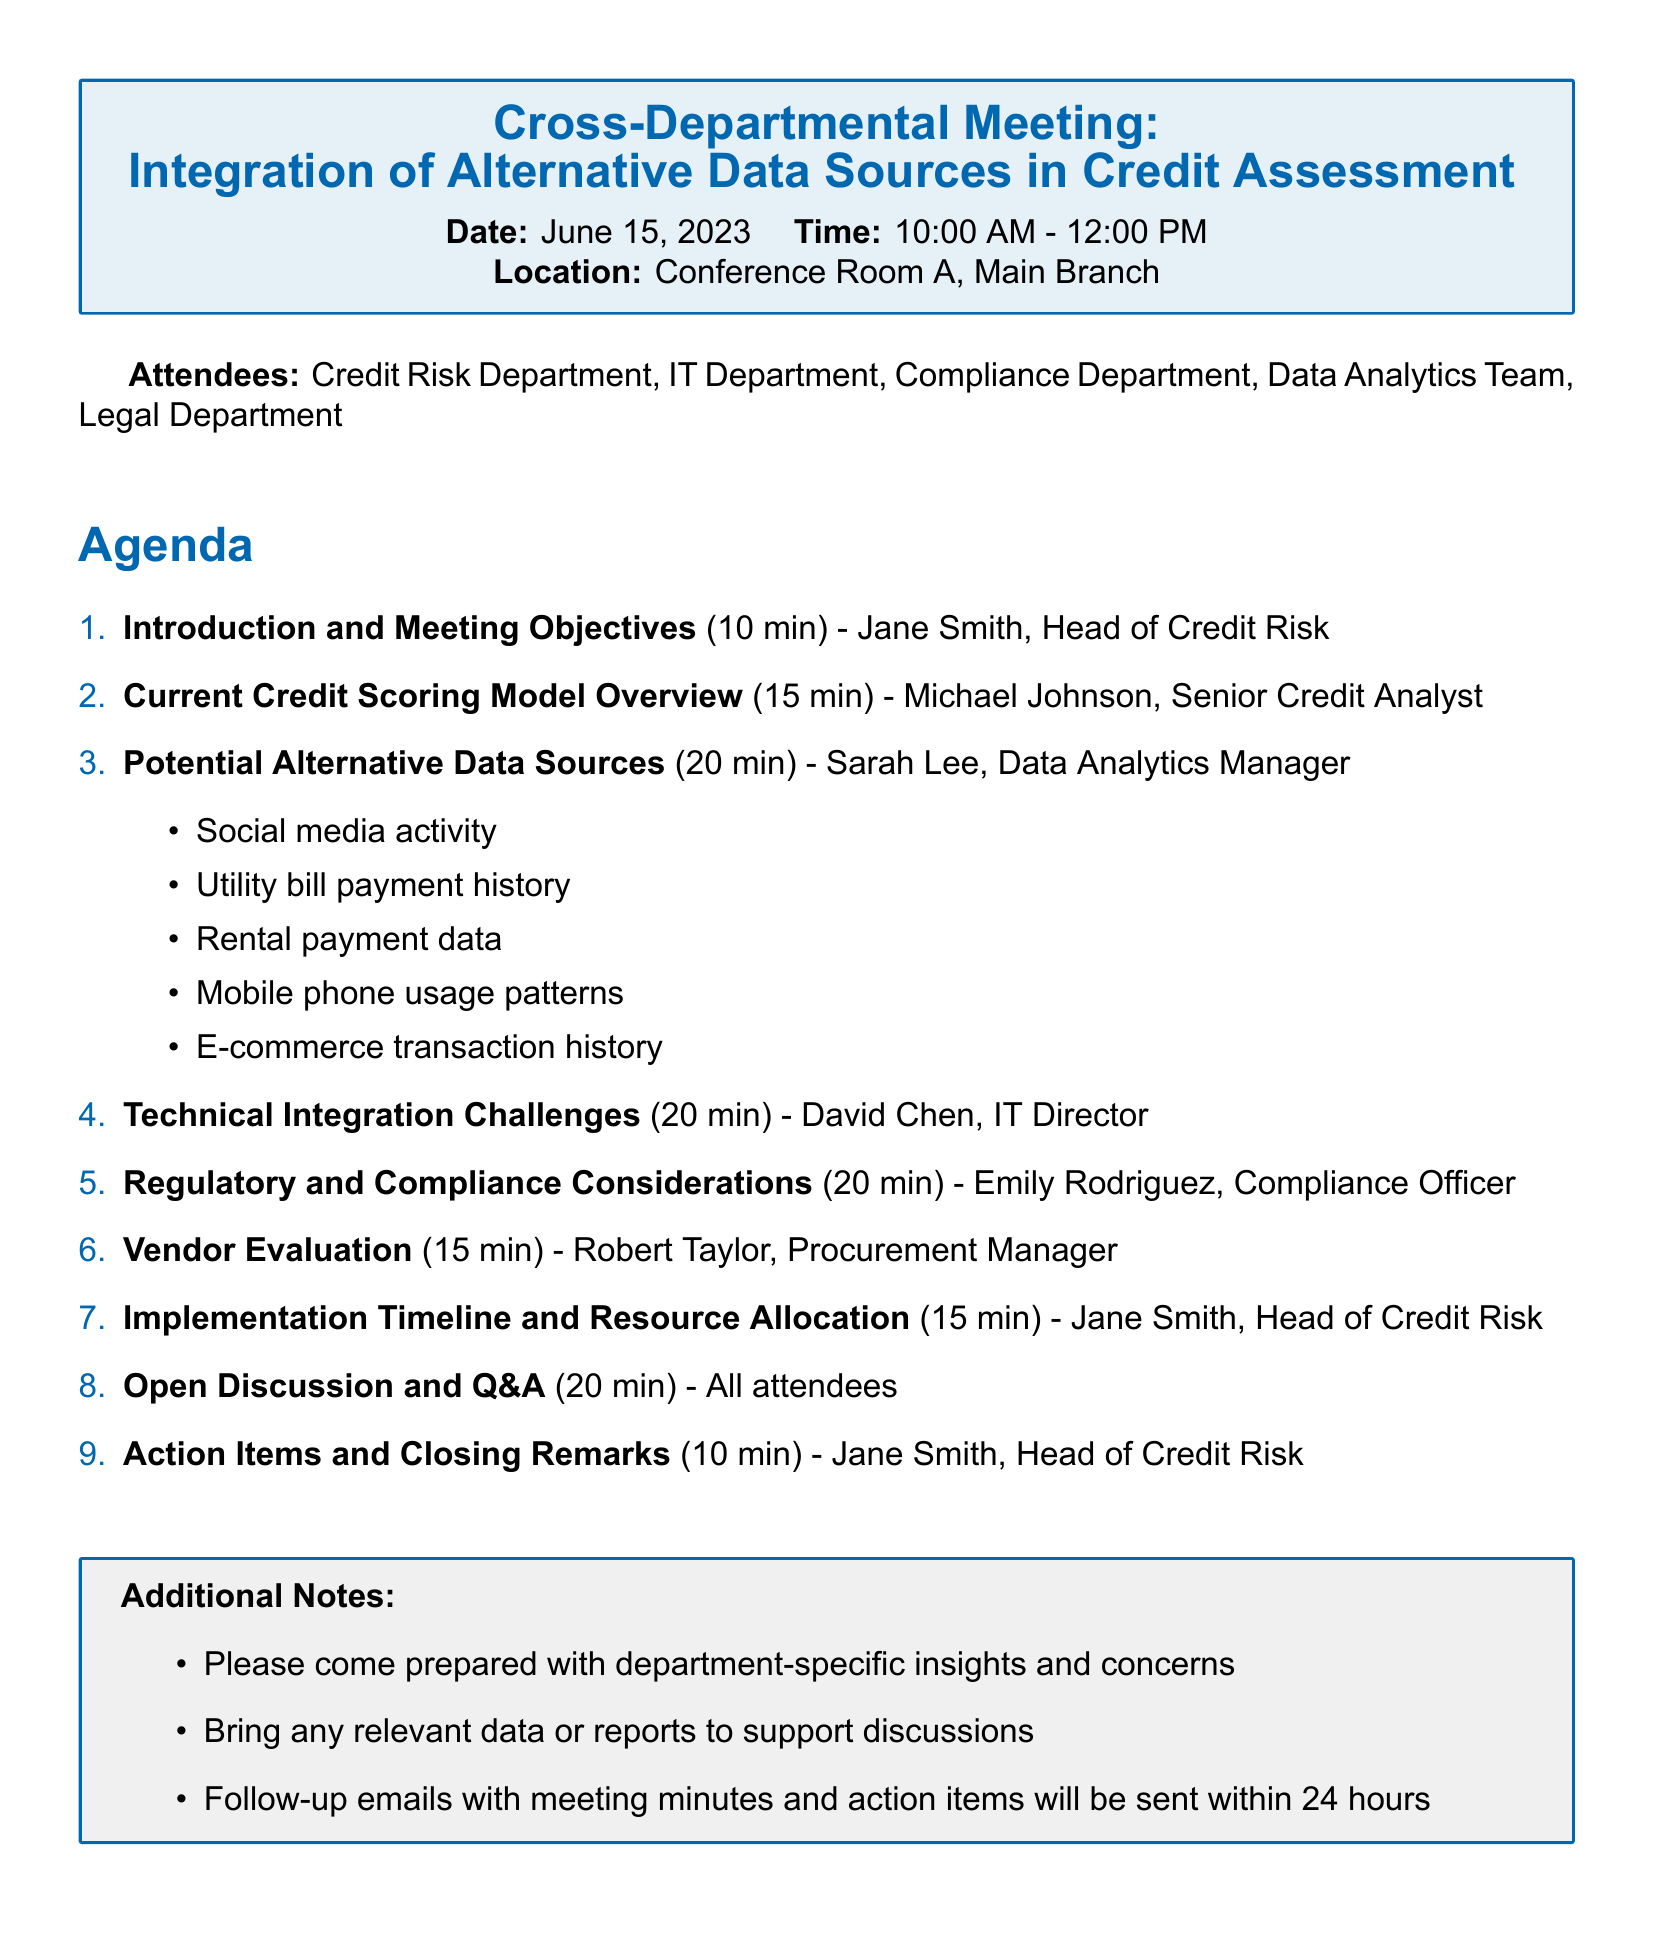What is the title of the meeting? The title of the meeting is explicitly stated at the top of the document.
Answer: Cross-Departmental Meeting: Integration of Alternative Data Sources in Credit Assessment Who is the presenter for the Current Credit Scoring Model Overview? The presenter's name is listed next to the agenda item.
Answer: Michael Johnson How long is allocated for the Open Discussion and Q&A? The duration is specified in the agenda item for that section.
Answer: 20 minutes What is one alternative data source mentioned? The document lists several alternative data sources under a specific agenda item.
Answer: Social media activity What are the compliance regulations mentioned during the meeting? The regulations that must be considered are listed under the relevant agenda item.
Answer: Fair Credit Reporting Act (FCRA) How many attendees are listed in the document? The number of attendees is provided in a bullet list within the document.
Answer: Five What is the duration of the Introduction and Meeting Objectives? The duration is given in parentheses next to the agenda item.
Answer: 10 minutes Who is responsible for the Implementation Timeline and Resource Allocation? The presenter for this agenda item is explicitly mentioned in the document.
Answer: Jane Smith 